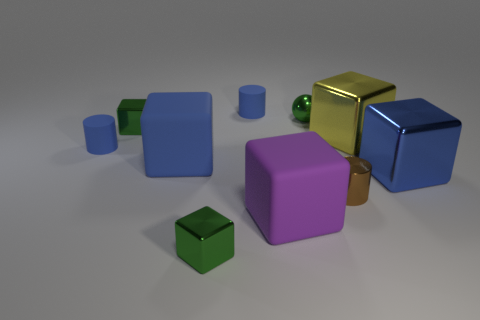Subtract all large rubber blocks. How many blocks are left? 4 Subtract all blue cylinders. How many cylinders are left? 1 Subtract 1 purple cubes. How many objects are left? 9 Subtract all spheres. How many objects are left? 9 Subtract 1 balls. How many balls are left? 0 Subtract all purple cylinders. Subtract all gray spheres. How many cylinders are left? 3 Subtract all purple balls. How many green blocks are left? 2 Subtract all big cubes. Subtract all small brown balls. How many objects are left? 6 Add 3 purple cubes. How many purple cubes are left? 4 Add 1 green metal cubes. How many green metal cubes exist? 3 